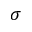Convert formula to latex. <formula><loc_0><loc_0><loc_500><loc_500>\sigma</formula> 